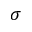Convert formula to latex. <formula><loc_0><loc_0><loc_500><loc_500>\sigma</formula> 